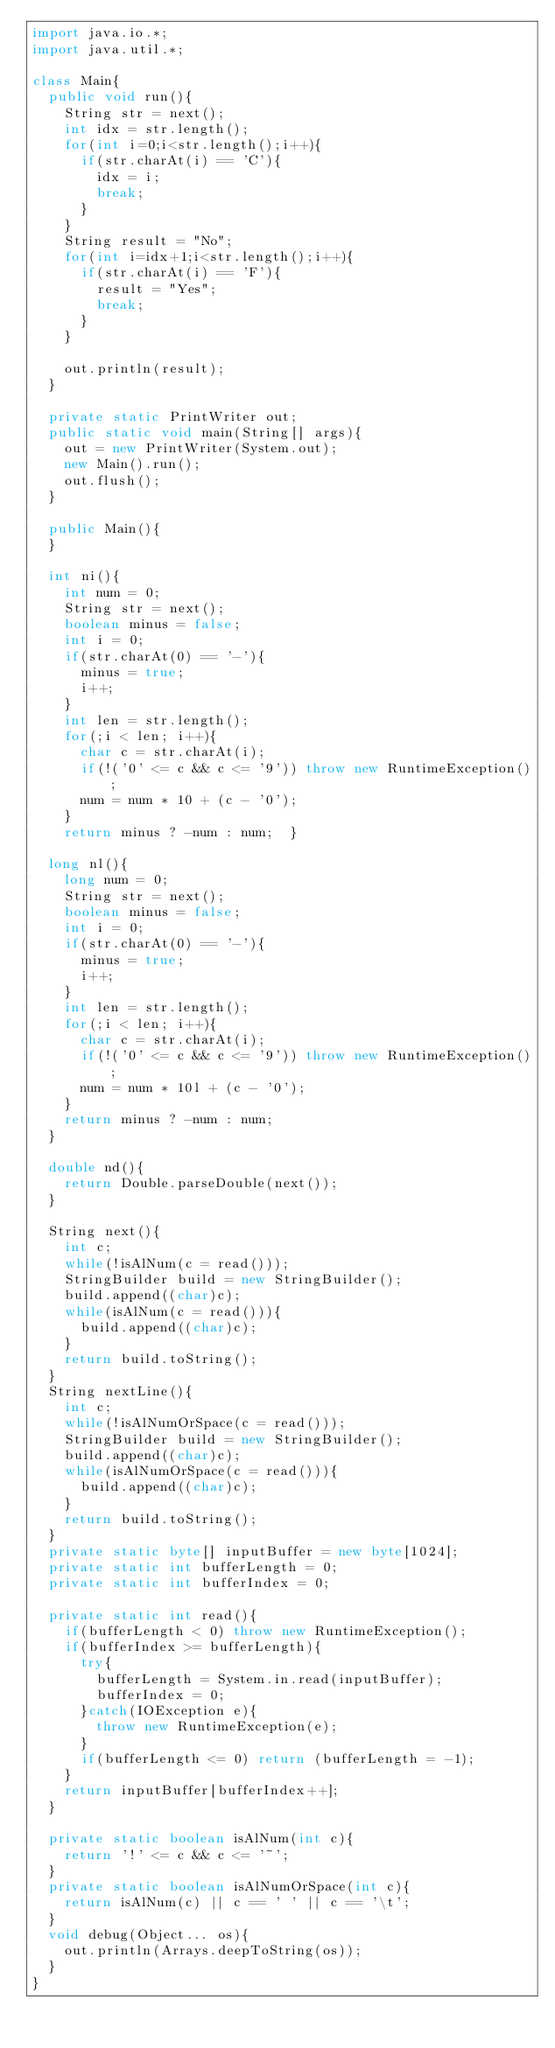<code> <loc_0><loc_0><loc_500><loc_500><_Java_>import java.io.*;
import java.util.*;

class Main{
	public void run(){
		String str = next();
		int idx = str.length();
		for(int i=0;i<str.length();i++){
			if(str.charAt(i) == 'C'){
				idx = i;
				break;
			}
		}
		String result = "No";
		for(int i=idx+1;i<str.length();i++){
			if(str.charAt(i) == 'F'){
				result = "Yes";
				break;
			}
		}

		out.println(result);
	}

	private static PrintWriter out;
	public static void main(String[] args){
		out = new PrintWriter(System.out);
		new Main().run();
		out.flush();
	}

	public Main(){
	}

	int ni(){
		int num = 0;
		String str = next();
		boolean minus = false;
		int i = 0;
		if(str.charAt(0) == '-'){
			minus = true;
			i++;
		}
		int len = str.length();
		for(;i < len; i++){
			char c = str.charAt(i);
			if(!('0' <= c && c <= '9')) throw new RuntimeException();
			num = num * 10 + (c - '0');
		}
		return minus ? -num : num;	}

	long nl(){
		long num = 0;
		String str = next();
		boolean minus = false;
		int i = 0;
		if(str.charAt(0) == '-'){
			minus = true;
			i++;
		}
		int len = str.length();
		for(;i < len; i++){
			char c = str.charAt(i);
			if(!('0' <= c && c <= '9')) throw new RuntimeException();
			num = num * 10l + (c - '0');
		}
		return minus ? -num : num;
	}

	double nd(){
		return Double.parseDouble(next());
	}

	String next(){
		int c;
		while(!isAlNum(c = read()));
		StringBuilder build = new StringBuilder();
		build.append((char)c);
		while(isAlNum(c = read())){
			build.append((char)c);
		}
		return build.toString();
	}
	String nextLine(){
		int c;
		while(!isAlNumOrSpace(c = read()));
		StringBuilder build = new StringBuilder();
		build.append((char)c);
		while(isAlNumOrSpace(c = read())){
			build.append((char)c);
		}
		return build.toString();
	}
	private static byte[] inputBuffer = new byte[1024];
	private static int bufferLength = 0;
	private static int bufferIndex = 0;
	
	private static int read(){
		if(bufferLength < 0) throw new RuntimeException();
		if(bufferIndex >= bufferLength){
			try{
				bufferLength = System.in.read(inputBuffer);
				bufferIndex = 0;
			}catch(IOException e){
				throw new RuntimeException(e);
			}
			if(bufferLength <= 0) return (bufferLength = -1);
		}
		return inputBuffer[bufferIndex++];
	}
	
	private static boolean isAlNum(int c){
		return '!' <= c && c <= '~';
	}
	private static boolean isAlNumOrSpace(int c){
		return isAlNum(c) || c == ' ' || c == '\t';
	}
	void debug(Object... os){
		out.println(Arrays.deepToString(os));
	}
}</code> 